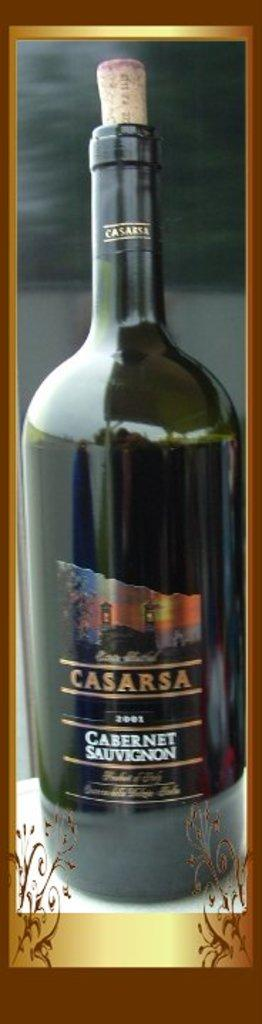<image>
Describe the image concisely. An opened, empty bottle of Casarsa cabernet sauvignon 